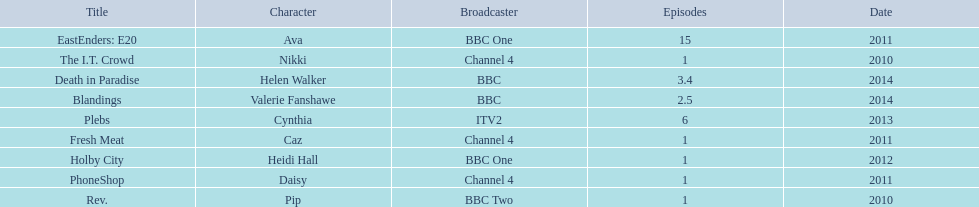How many episodes did sophie colquhoun star in on rev.? 1. What character did she play on phoneshop? Daisy. What role did she play on itv2? Cynthia. 